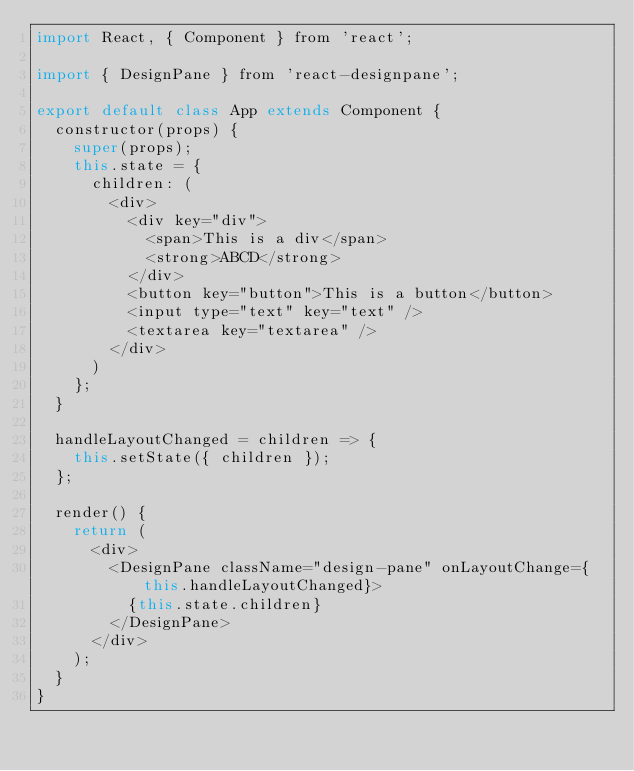Convert code to text. <code><loc_0><loc_0><loc_500><loc_500><_JavaScript_>import React, { Component } from 'react';

import { DesignPane } from 'react-designpane';

export default class App extends Component {
  constructor(props) {
    super(props);
    this.state = {
      children: (
        <div>
          <div key="div">
            <span>This is a div</span>
            <strong>ABCD</strong>
          </div>
          <button key="button">This is a button</button>
          <input type="text" key="text" />
          <textarea key="textarea" />
        </div>
      )
    };
  }

  handleLayoutChanged = children => {
    this.setState({ children });
  };

  render() {
    return (
      <div>
        <DesignPane className="design-pane" onLayoutChange={this.handleLayoutChanged}>
          {this.state.children}
        </DesignPane>
      </div>
    );
  }
}
</code> 